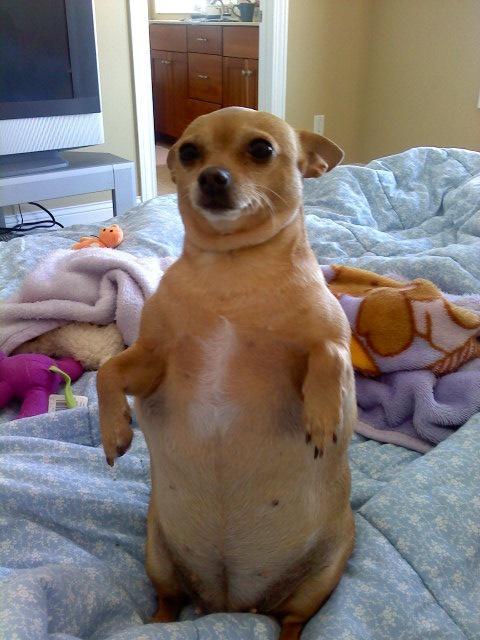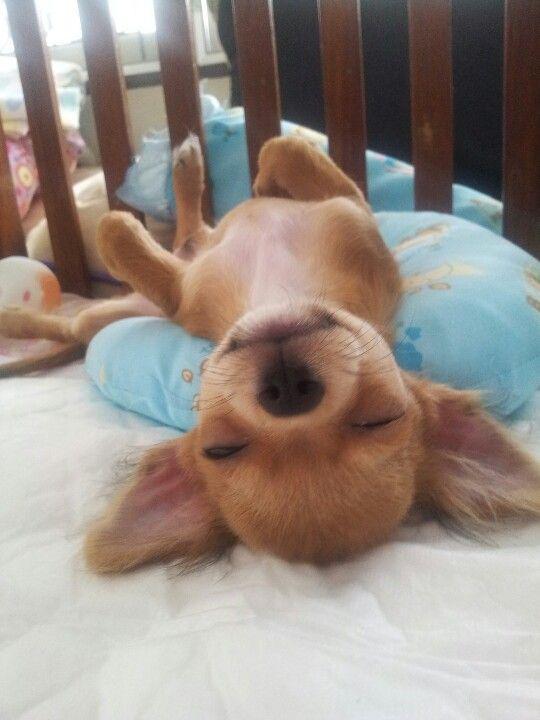The first image is the image on the left, the second image is the image on the right. Considering the images on both sides, is "Both images show a chihuahua dog in a snoozing pose, but only one dog has its eyes completely shut." valid? Answer yes or no. No. The first image is the image on the left, the second image is the image on the right. Considering the images on both sides, is "The eyes of the dog in the image on the right are half open." valid? Answer yes or no. No. 